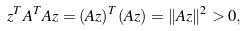<formula> <loc_0><loc_0><loc_500><loc_500>z ^ { T } A ^ { T } A z = ( A z ) ^ { T } ( A z ) = \| A z \| ^ { 2 } > 0 ,</formula> 